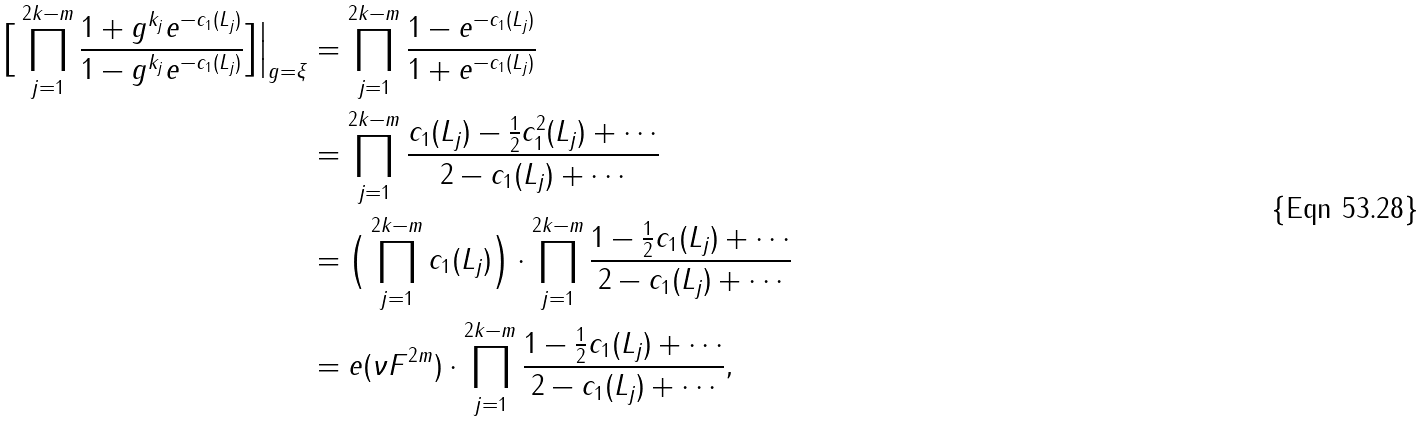<formula> <loc_0><loc_0><loc_500><loc_500>\Big [ \prod _ { j = 1 } ^ { 2 k - m } \frac { 1 + g ^ { k _ { j } } e ^ { - c _ { 1 } ( L _ { j } ) } } { 1 - g ^ { k _ { j } } e ^ { - c _ { 1 } ( L _ { j } ) } } \Big ] \Big | _ { g = \xi } & = \prod _ { j = 1 } ^ { 2 k - m } \frac { 1 - e ^ { - c _ { 1 } ( L _ { j } ) } } { 1 + e ^ { - c _ { 1 } ( L _ { j } ) } } \\ & = \prod _ { j = 1 } ^ { 2 k - m } \frac { c _ { 1 } ( L _ { j } ) - \frac { 1 } { 2 } c _ { 1 } ^ { 2 } ( L _ { j } ) + \cdots } { 2 - c _ { 1 } ( L _ { j } ) + \cdots } \\ & = \Big ( \prod _ { j = 1 } ^ { 2 k - m } c _ { 1 } ( L _ { j } ) \Big ) \cdot \prod _ { j = 1 } ^ { 2 k - m } \frac { 1 - \frac { 1 } { 2 } c _ { 1 } ( L _ { j } ) + \cdots } { 2 - c _ { 1 } ( L _ { j } ) + \cdots } \\ & = e ( \nu F ^ { 2 m } ) \cdot \prod _ { j = 1 } ^ { 2 k - m } \frac { 1 - \frac { 1 } { 2 } c _ { 1 } ( L _ { j } ) + \cdots } { 2 - c _ { 1 } ( L _ { j } ) + \cdots } ,</formula> 